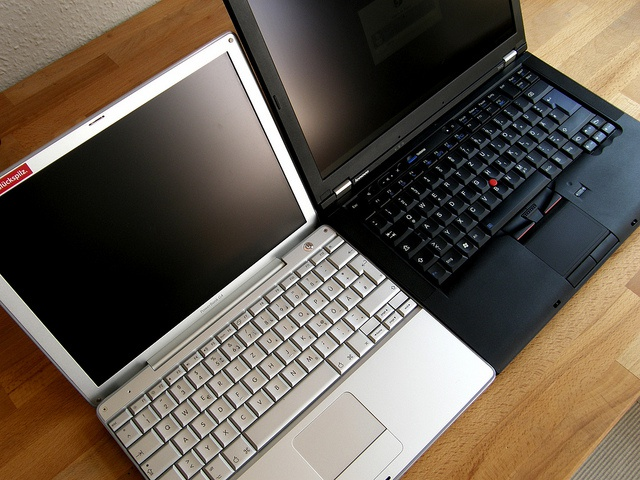Describe the objects in this image and their specific colors. I can see laptop in gray, black, lightgray, and darkgray tones, laptop in gray, black, and blue tones, keyboard in gray, darkgray, lightgray, and black tones, and keyboard in gray, black, and blue tones in this image. 